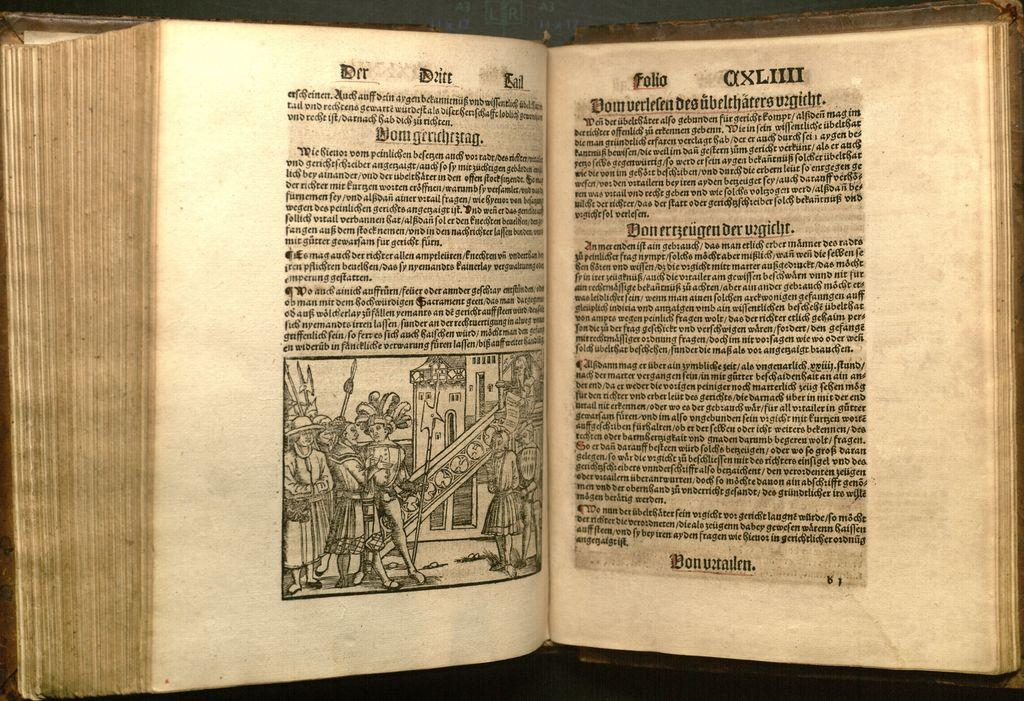<image>
Provide a brief description of the given image. A very old book showing men carrying a ladder is open to page AXLIII. 